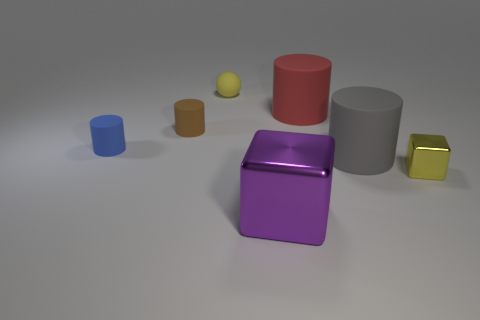What is the size of the metal block that is the same color as the rubber sphere?
Give a very brief answer. Small. The tiny thing that is the same color as the tiny cube is what shape?
Your answer should be compact. Sphere. Is the size of the metallic cube that is to the right of the gray cylinder the same as the red matte cylinder?
Provide a succinct answer. No. There is a tiny yellow object in front of the yellow rubber ball; what is its material?
Your response must be concise. Metal. Is the number of rubber cylinders that are left of the small brown thing the same as the number of blue cylinders left of the large red matte thing?
Offer a terse response. Yes. What is the color of the other large rubber object that is the same shape as the large red matte object?
Offer a very short reply. Gray. Is there anything else that has the same color as the small metallic thing?
Your answer should be compact. Yes. What number of rubber objects are brown cylinders or blue objects?
Your answer should be compact. 2. Is the matte ball the same color as the big cube?
Your answer should be very brief. No. Is the number of small yellow shiny blocks in front of the tiny metal cube greater than the number of brown objects?
Provide a succinct answer. No. 